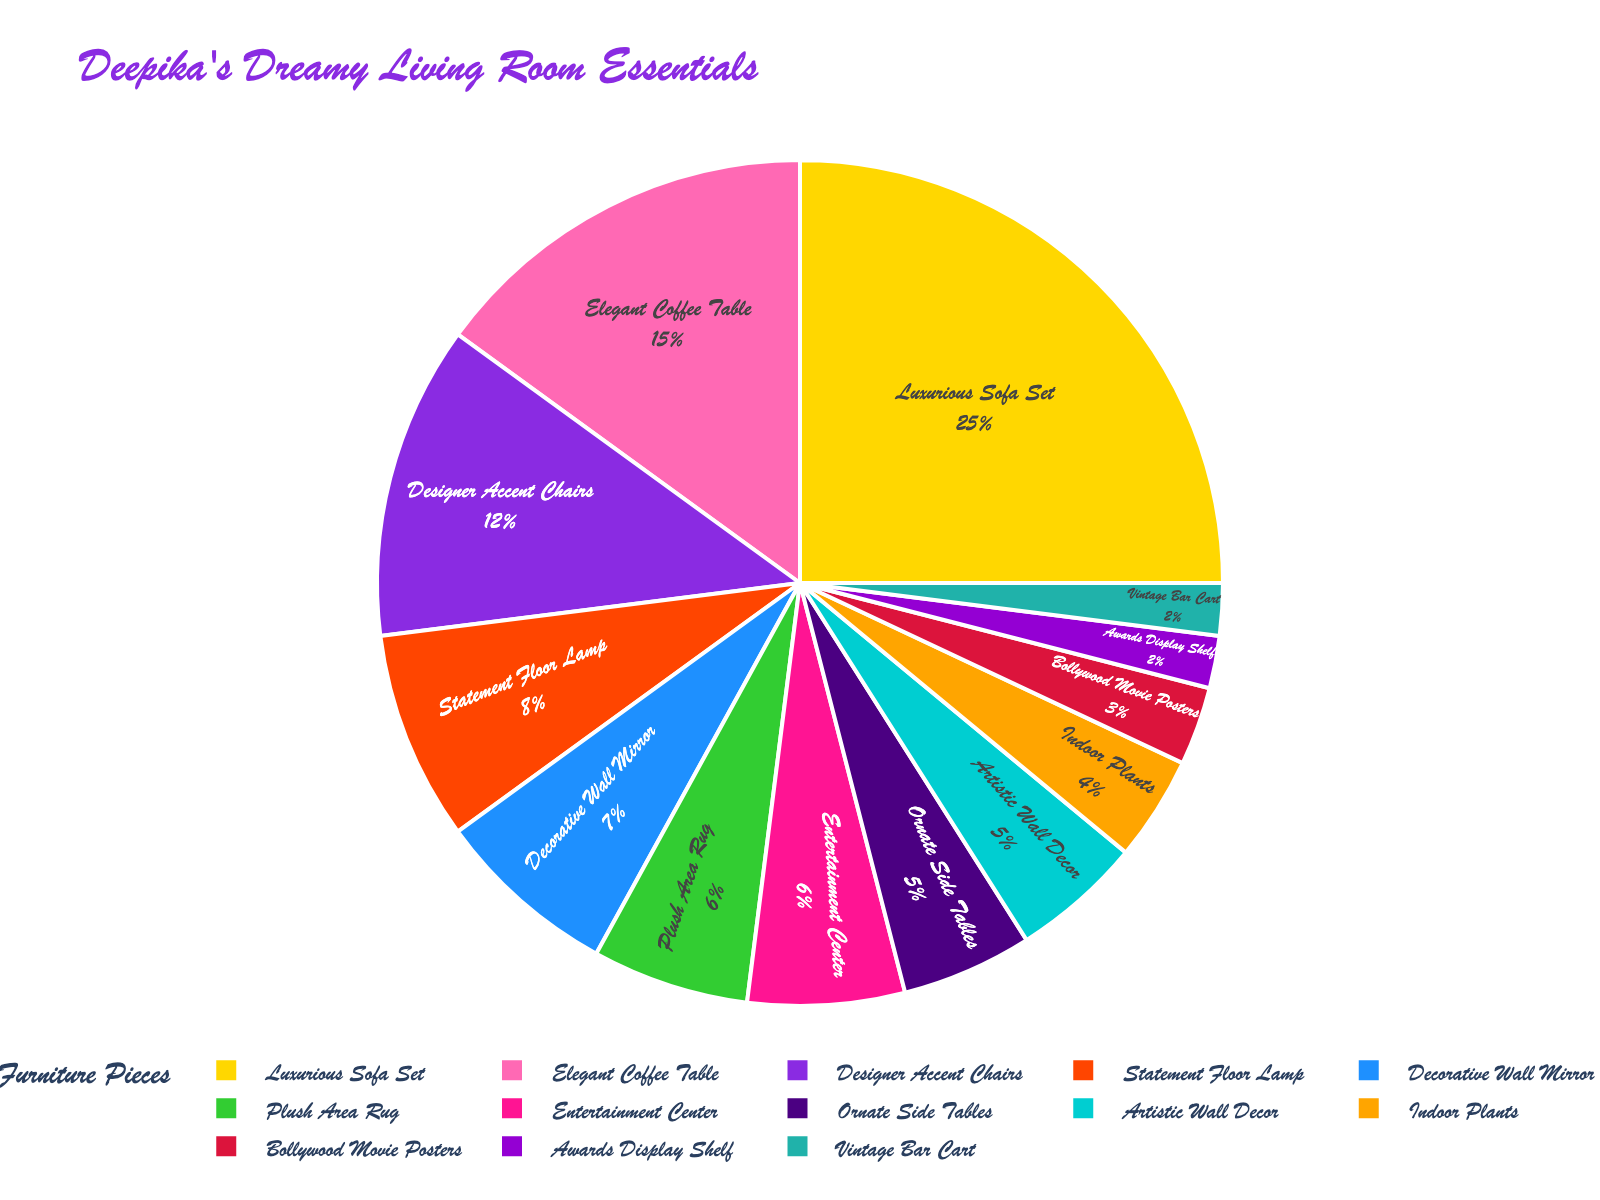What is the most dominant type of furniture in the living room? The pie chart shows that the Luxurious Sofa Set category occupies the largest segment with 25% of the total.
Answer: Luxurious Sofa Set Which piece of furniture takes up less space: Elegant Coffee Table or Designer Accent Chairs? By comparing the percentages on the pie chart, the Elegant Coffee Table occupies 15% while the Designer Accent Chairs take up 12%. Thus, Designer Accent Chairs take up less space.
Answer: Designer Accent Chairs How much more space does the Luxurious Sofa Set take up compared to the Bollywood Movie Posters? The Luxurious Sofa Set occupies 25%, while Bollywood Movie Posters occupy 3%. The difference is 25% - 3% = 22%.
Answer: 22% What is the combined proportion of Statement Floor Lamp, Decorative Wall Mirror, and Plush Area Rug? The pie chart shows that Statement Floor Lamp has 8%, Decorative Wall Mirror has 7%, and Plush Area Rug has 6%. Their combined proportion is 8% + 7% + 6% = 21%.
Answer: 21% Which color represents the Ornate Side Tables? Based on the custom color palette used in the pie chart, the color representing Ornate Side Tables is purple.
Answer: Purple Is the proportion of Indoor Plants higher, lower, or equal to the proportion of Artistic Wall Decor? Comparing the pie chart segments, Indoor Plants occupy 4% while Artistic Wall Decor occupies 5%. Thus, the proportion of Indoor Plants is lower.
Answer: Lower How many types of furniture occupy less than 5% of the space each? The pie chart shows that Bollywood Movie Posters (3%), Awards Display Shelf (2%), and Vintage Bar Cart (2%) each take up less than 5% of the space, making a total of 3 types.
Answer: 3 What is the second largest segment in the pie chart? The pie chart shows the second largest segment is the Elegant Coffee Table, which occupies 15% of the total.
Answer: Elegant Coffee Table How does the combined percentage of Entertainment Center and Artistic Wall Decor compare to the percentage of Luxurious Sofa Set? Entertainment Center is 6% and Artistic Wall Decor is 5%. Their combined percentage is 6% + 5% = 11%, whereas the Luxurious Sofa Set is 25%. The combined percentage is less than the Luxurious Sofa Set.
Answer: Less What is the total percentage taken up by furniture related to decor (i.e., items like Decorative Wall Mirror and Artistic Wall Decor)? The decorative items are Decorative Wall Mirror (7%) and Artistic Wall Decor (5%). The total percentage is 7% + 5% = 12%.
Answer: 12% 